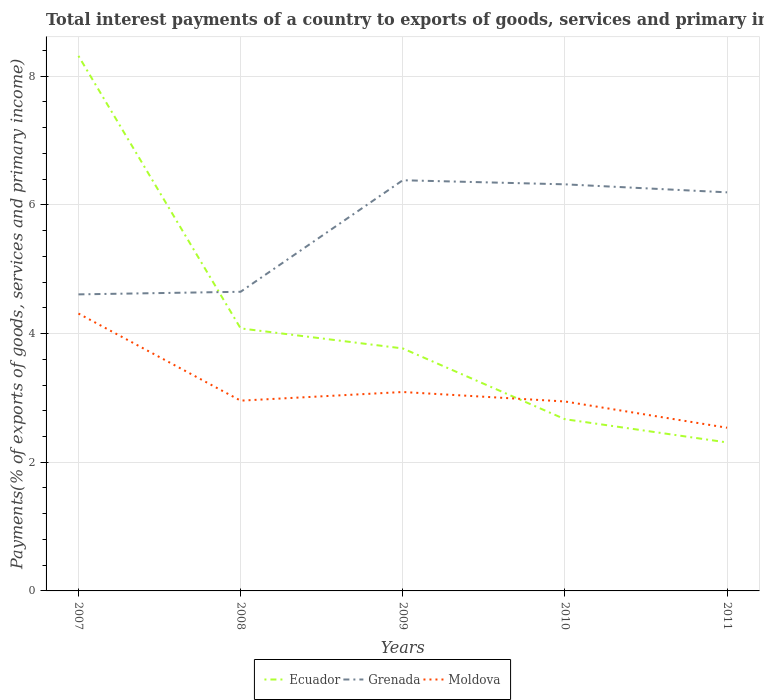How many different coloured lines are there?
Ensure brevity in your answer.  3. Across all years, what is the maximum total interest payments in Grenada?
Your answer should be compact. 4.61. In which year was the total interest payments in Moldova maximum?
Your answer should be compact. 2011. What is the total total interest payments in Ecuador in the graph?
Make the answer very short. 4.23. What is the difference between the highest and the second highest total interest payments in Moldova?
Ensure brevity in your answer.  1.77. What is the difference between the highest and the lowest total interest payments in Moldova?
Offer a terse response. 1. What is the difference between two consecutive major ticks on the Y-axis?
Your response must be concise. 2. Are the values on the major ticks of Y-axis written in scientific E-notation?
Offer a terse response. No. What is the title of the graph?
Ensure brevity in your answer.  Total interest payments of a country to exports of goods, services and primary income. What is the label or title of the X-axis?
Provide a succinct answer. Years. What is the label or title of the Y-axis?
Your answer should be very brief. Payments(% of exports of goods, services and primary income). What is the Payments(% of exports of goods, services and primary income) in Ecuador in 2007?
Make the answer very short. 8.32. What is the Payments(% of exports of goods, services and primary income) of Grenada in 2007?
Provide a succinct answer. 4.61. What is the Payments(% of exports of goods, services and primary income) in Moldova in 2007?
Make the answer very short. 4.31. What is the Payments(% of exports of goods, services and primary income) of Ecuador in 2008?
Offer a very short reply. 4.08. What is the Payments(% of exports of goods, services and primary income) of Grenada in 2008?
Your answer should be very brief. 4.65. What is the Payments(% of exports of goods, services and primary income) in Moldova in 2008?
Offer a very short reply. 2.96. What is the Payments(% of exports of goods, services and primary income) in Ecuador in 2009?
Your response must be concise. 3.77. What is the Payments(% of exports of goods, services and primary income) in Grenada in 2009?
Make the answer very short. 6.38. What is the Payments(% of exports of goods, services and primary income) in Moldova in 2009?
Ensure brevity in your answer.  3.09. What is the Payments(% of exports of goods, services and primary income) of Ecuador in 2010?
Provide a short and direct response. 2.67. What is the Payments(% of exports of goods, services and primary income) of Grenada in 2010?
Your response must be concise. 6.32. What is the Payments(% of exports of goods, services and primary income) of Moldova in 2010?
Provide a short and direct response. 2.94. What is the Payments(% of exports of goods, services and primary income) of Ecuador in 2011?
Provide a succinct answer. 2.31. What is the Payments(% of exports of goods, services and primary income) in Grenada in 2011?
Ensure brevity in your answer.  6.19. What is the Payments(% of exports of goods, services and primary income) of Moldova in 2011?
Offer a very short reply. 2.54. Across all years, what is the maximum Payments(% of exports of goods, services and primary income) in Ecuador?
Offer a terse response. 8.32. Across all years, what is the maximum Payments(% of exports of goods, services and primary income) in Grenada?
Ensure brevity in your answer.  6.38. Across all years, what is the maximum Payments(% of exports of goods, services and primary income) in Moldova?
Your response must be concise. 4.31. Across all years, what is the minimum Payments(% of exports of goods, services and primary income) in Ecuador?
Your answer should be compact. 2.31. Across all years, what is the minimum Payments(% of exports of goods, services and primary income) of Grenada?
Provide a succinct answer. 4.61. Across all years, what is the minimum Payments(% of exports of goods, services and primary income) of Moldova?
Ensure brevity in your answer.  2.54. What is the total Payments(% of exports of goods, services and primary income) in Ecuador in the graph?
Offer a terse response. 21.14. What is the total Payments(% of exports of goods, services and primary income) in Grenada in the graph?
Offer a terse response. 28.15. What is the total Payments(% of exports of goods, services and primary income) of Moldova in the graph?
Your answer should be compact. 15.84. What is the difference between the Payments(% of exports of goods, services and primary income) in Ecuador in 2007 and that in 2008?
Offer a terse response. 4.24. What is the difference between the Payments(% of exports of goods, services and primary income) of Grenada in 2007 and that in 2008?
Make the answer very short. -0.04. What is the difference between the Payments(% of exports of goods, services and primary income) in Moldova in 2007 and that in 2008?
Offer a very short reply. 1.35. What is the difference between the Payments(% of exports of goods, services and primary income) in Ecuador in 2007 and that in 2009?
Offer a terse response. 4.55. What is the difference between the Payments(% of exports of goods, services and primary income) of Grenada in 2007 and that in 2009?
Provide a succinct answer. -1.77. What is the difference between the Payments(% of exports of goods, services and primary income) of Moldova in 2007 and that in 2009?
Ensure brevity in your answer.  1.22. What is the difference between the Payments(% of exports of goods, services and primary income) of Ecuador in 2007 and that in 2010?
Provide a succinct answer. 5.65. What is the difference between the Payments(% of exports of goods, services and primary income) in Grenada in 2007 and that in 2010?
Ensure brevity in your answer.  -1.71. What is the difference between the Payments(% of exports of goods, services and primary income) in Moldova in 2007 and that in 2010?
Your answer should be very brief. 1.37. What is the difference between the Payments(% of exports of goods, services and primary income) of Ecuador in 2007 and that in 2011?
Your answer should be compact. 6.01. What is the difference between the Payments(% of exports of goods, services and primary income) in Grenada in 2007 and that in 2011?
Provide a short and direct response. -1.59. What is the difference between the Payments(% of exports of goods, services and primary income) in Moldova in 2007 and that in 2011?
Give a very brief answer. 1.77. What is the difference between the Payments(% of exports of goods, services and primary income) of Ecuador in 2008 and that in 2009?
Offer a very short reply. 0.31. What is the difference between the Payments(% of exports of goods, services and primary income) of Grenada in 2008 and that in 2009?
Your response must be concise. -1.73. What is the difference between the Payments(% of exports of goods, services and primary income) in Moldova in 2008 and that in 2009?
Offer a terse response. -0.13. What is the difference between the Payments(% of exports of goods, services and primary income) of Ecuador in 2008 and that in 2010?
Make the answer very short. 1.41. What is the difference between the Payments(% of exports of goods, services and primary income) in Grenada in 2008 and that in 2010?
Keep it short and to the point. -1.67. What is the difference between the Payments(% of exports of goods, services and primary income) of Moldova in 2008 and that in 2010?
Give a very brief answer. 0.01. What is the difference between the Payments(% of exports of goods, services and primary income) in Ecuador in 2008 and that in 2011?
Offer a very short reply. 1.77. What is the difference between the Payments(% of exports of goods, services and primary income) in Grenada in 2008 and that in 2011?
Your response must be concise. -1.55. What is the difference between the Payments(% of exports of goods, services and primary income) in Moldova in 2008 and that in 2011?
Your answer should be very brief. 0.42. What is the difference between the Payments(% of exports of goods, services and primary income) of Ecuador in 2009 and that in 2010?
Ensure brevity in your answer.  1.1. What is the difference between the Payments(% of exports of goods, services and primary income) in Grenada in 2009 and that in 2010?
Make the answer very short. 0.06. What is the difference between the Payments(% of exports of goods, services and primary income) in Moldova in 2009 and that in 2010?
Your answer should be very brief. 0.15. What is the difference between the Payments(% of exports of goods, services and primary income) in Ecuador in 2009 and that in 2011?
Provide a short and direct response. 1.46. What is the difference between the Payments(% of exports of goods, services and primary income) in Grenada in 2009 and that in 2011?
Your response must be concise. 0.19. What is the difference between the Payments(% of exports of goods, services and primary income) of Moldova in 2009 and that in 2011?
Your response must be concise. 0.56. What is the difference between the Payments(% of exports of goods, services and primary income) of Ecuador in 2010 and that in 2011?
Provide a succinct answer. 0.36. What is the difference between the Payments(% of exports of goods, services and primary income) of Grenada in 2010 and that in 2011?
Provide a short and direct response. 0.12. What is the difference between the Payments(% of exports of goods, services and primary income) in Moldova in 2010 and that in 2011?
Your answer should be very brief. 0.41. What is the difference between the Payments(% of exports of goods, services and primary income) of Ecuador in 2007 and the Payments(% of exports of goods, services and primary income) of Grenada in 2008?
Your answer should be very brief. 3.67. What is the difference between the Payments(% of exports of goods, services and primary income) of Ecuador in 2007 and the Payments(% of exports of goods, services and primary income) of Moldova in 2008?
Provide a succinct answer. 5.36. What is the difference between the Payments(% of exports of goods, services and primary income) of Grenada in 2007 and the Payments(% of exports of goods, services and primary income) of Moldova in 2008?
Offer a very short reply. 1.65. What is the difference between the Payments(% of exports of goods, services and primary income) in Ecuador in 2007 and the Payments(% of exports of goods, services and primary income) in Grenada in 2009?
Your answer should be compact. 1.93. What is the difference between the Payments(% of exports of goods, services and primary income) in Ecuador in 2007 and the Payments(% of exports of goods, services and primary income) in Moldova in 2009?
Offer a terse response. 5.22. What is the difference between the Payments(% of exports of goods, services and primary income) in Grenada in 2007 and the Payments(% of exports of goods, services and primary income) in Moldova in 2009?
Provide a succinct answer. 1.52. What is the difference between the Payments(% of exports of goods, services and primary income) in Ecuador in 2007 and the Payments(% of exports of goods, services and primary income) in Grenada in 2010?
Keep it short and to the point. 2. What is the difference between the Payments(% of exports of goods, services and primary income) of Ecuador in 2007 and the Payments(% of exports of goods, services and primary income) of Moldova in 2010?
Your answer should be compact. 5.37. What is the difference between the Payments(% of exports of goods, services and primary income) in Grenada in 2007 and the Payments(% of exports of goods, services and primary income) in Moldova in 2010?
Ensure brevity in your answer.  1.66. What is the difference between the Payments(% of exports of goods, services and primary income) in Ecuador in 2007 and the Payments(% of exports of goods, services and primary income) in Grenada in 2011?
Provide a short and direct response. 2.12. What is the difference between the Payments(% of exports of goods, services and primary income) of Ecuador in 2007 and the Payments(% of exports of goods, services and primary income) of Moldova in 2011?
Your answer should be very brief. 5.78. What is the difference between the Payments(% of exports of goods, services and primary income) of Grenada in 2007 and the Payments(% of exports of goods, services and primary income) of Moldova in 2011?
Offer a terse response. 2.07. What is the difference between the Payments(% of exports of goods, services and primary income) in Ecuador in 2008 and the Payments(% of exports of goods, services and primary income) in Grenada in 2009?
Ensure brevity in your answer.  -2.3. What is the difference between the Payments(% of exports of goods, services and primary income) of Ecuador in 2008 and the Payments(% of exports of goods, services and primary income) of Moldova in 2009?
Ensure brevity in your answer.  0.99. What is the difference between the Payments(% of exports of goods, services and primary income) of Grenada in 2008 and the Payments(% of exports of goods, services and primary income) of Moldova in 2009?
Offer a very short reply. 1.56. What is the difference between the Payments(% of exports of goods, services and primary income) of Ecuador in 2008 and the Payments(% of exports of goods, services and primary income) of Grenada in 2010?
Give a very brief answer. -2.24. What is the difference between the Payments(% of exports of goods, services and primary income) of Ecuador in 2008 and the Payments(% of exports of goods, services and primary income) of Moldova in 2010?
Ensure brevity in your answer.  1.14. What is the difference between the Payments(% of exports of goods, services and primary income) of Grenada in 2008 and the Payments(% of exports of goods, services and primary income) of Moldova in 2010?
Your answer should be very brief. 1.71. What is the difference between the Payments(% of exports of goods, services and primary income) in Ecuador in 2008 and the Payments(% of exports of goods, services and primary income) in Grenada in 2011?
Make the answer very short. -2.11. What is the difference between the Payments(% of exports of goods, services and primary income) in Ecuador in 2008 and the Payments(% of exports of goods, services and primary income) in Moldova in 2011?
Give a very brief answer. 1.54. What is the difference between the Payments(% of exports of goods, services and primary income) of Grenada in 2008 and the Payments(% of exports of goods, services and primary income) of Moldova in 2011?
Offer a terse response. 2.11. What is the difference between the Payments(% of exports of goods, services and primary income) of Ecuador in 2009 and the Payments(% of exports of goods, services and primary income) of Grenada in 2010?
Provide a short and direct response. -2.55. What is the difference between the Payments(% of exports of goods, services and primary income) of Ecuador in 2009 and the Payments(% of exports of goods, services and primary income) of Moldova in 2010?
Keep it short and to the point. 0.82. What is the difference between the Payments(% of exports of goods, services and primary income) of Grenada in 2009 and the Payments(% of exports of goods, services and primary income) of Moldova in 2010?
Your response must be concise. 3.44. What is the difference between the Payments(% of exports of goods, services and primary income) of Ecuador in 2009 and the Payments(% of exports of goods, services and primary income) of Grenada in 2011?
Give a very brief answer. -2.43. What is the difference between the Payments(% of exports of goods, services and primary income) in Ecuador in 2009 and the Payments(% of exports of goods, services and primary income) in Moldova in 2011?
Provide a short and direct response. 1.23. What is the difference between the Payments(% of exports of goods, services and primary income) in Grenada in 2009 and the Payments(% of exports of goods, services and primary income) in Moldova in 2011?
Ensure brevity in your answer.  3.85. What is the difference between the Payments(% of exports of goods, services and primary income) in Ecuador in 2010 and the Payments(% of exports of goods, services and primary income) in Grenada in 2011?
Make the answer very short. -3.53. What is the difference between the Payments(% of exports of goods, services and primary income) in Ecuador in 2010 and the Payments(% of exports of goods, services and primary income) in Moldova in 2011?
Ensure brevity in your answer.  0.13. What is the difference between the Payments(% of exports of goods, services and primary income) of Grenada in 2010 and the Payments(% of exports of goods, services and primary income) of Moldova in 2011?
Offer a terse response. 3.78. What is the average Payments(% of exports of goods, services and primary income) of Ecuador per year?
Make the answer very short. 4.23. What is the average Payments(% of exports of goods, services and primary income) of Grenada per year?
Make the answer very short. 5.63. What is the average Payments(% of exports of goods, services and primary income) of Moldova per year?
Offer a very short reply. 3.17. In the year 2007, what is the difference between the Payments(% of exports of goods, services and primary income) in Ecuador and Payments(% of exports of goods, services and primary income) in Grenada?
Provide a short and direct response. 3.71. In the year 2007, what is the difference between the Payments(% of exports of goods, services and primary income) of Ecuador and Payments(% of exports of goods, services and primary income) of Moldova?
Offer a very short reply. 4. In the year 2007, what is the difference between the Payments(% of exports of goods, services and primary income) in Grenada and Payments(% of exports of goods, services and primary income) in Moldova?
Offer a very short reply. 0.3. In the year 2008, what is the difference between the Payments(% of exports of goods, services and primary income) of Ecuador and Payments(% of exports of goods, services and primary income) of Grenada?
Provide a succinct answer. -0.57. In the year 2008, what is the difference between the Payments(% of exports of goods, services and primary income) of Ecuador and Payments(% of exports of goods, services and primary income) of Moldova?
Ensure brevity in your answer.  1.12. In the year 2008, what is the difference between the Payments(% of exports of goods, services and primary income) of Grenada and Payments(% of exports of goods, services and primary income) of Moldova?
Your answer should be very brief. 1.69. In the year 2009, what is the difference between the Payments(% of exports of goods, services and primary income) of Ecuador and Payments(% of exports of goods, services and primary income) of Grenada?
Make the answer very short. -2.61. In the year 2009, what is the difference between the Payments(% of exports of goods, services and primary income) of Ecuador and Payments(% of exports of goods, services and primary income) of Moldova?
Make the answer very short. 0.68. In the year 2009, what is the difference between the Payments(% of exports of goods, services and primary income) in Grenada and Payments(% of exports of goods, services and primary income) in Moldova?
Ensure brevity in your answer.  3.29. In the year 2010, what is the difference between the Payments(% of exports of goods, services and primary income) of Ecuador and Payments(% of exports of goods, services and primary income) of Grenada?
Provide a succinct answer. -3.65. In the year 2010, what is the difference between the Payments(% of exports of goods, services and primary income) of Ecuador and Payments(% of exports of goods, services and primary income) of Moldova?
Ensure brevity in your answer.  -0.28. In the year 2010, what is the difference between the Payments(% of exports of goods, services and primary income) in Grenada and Payments(% of exports of goods, services and primary income) in Moldova?
Offer a terse response. 3.37. In the year 2011, what is the difference between the Payments(% of exports of goods, services and primary income) of Ecuador and Payments(% of exports of goods, services and primary income) of Grenada?
Provide a succinct answer. -3.89. In the year 2011, what is the difference between the Payments(% of exports of goods, services and primary income) in Ecuador and Payments(% of exports of goods, services and primary income) in Moldova?
Make the answer very short. -0.23. In the year 2011, what is the difference between the Payments(% of exports of goods, services and primary income) of Grenada and Payments(% of exports of goods, services and primary income) of Moldova?
Your response must be concise. 3.66. What is the ratio of the Payments(% of exports of goods, services and primary income) in Ecuador in 2007 to that in 2008?
Make the answer very short. 2.04. What is the ratio of the Payments(% of exports of goods, services and primary income) in Grenada in 2007 to that in 2008?
Your answer should be very brief. 0.99. What is the ratio of the Payments(% of exports of goods, services and primary income) in Moldova in 2007 to that in 2008?
Give a very brief answer. 1.46. What is the ratio of the Payments(% of exports of goods, services and primary income) of Ecuador in 2007 to that in 2009?
Make the answer very short. 2.21. What is the ratio of the Payments(% of exports of goods, services and primary income) in Grenada in 2007 to that in 2009?
Ensure brevity in your answer.  0.72. What is the ratio of the Payments(% of exports of goods, services and primary income) in Moldova in 2007 to that in 2009?
Offer a terse response. 1.39. What is the ratio of the Payments(% of exports of goods, services and primary income) in Ecuador in 2007 to that in 2010?
Offer a terse response. 3.12. What is the ratio of the Payments(% of exports of goods, services and primary income) in Grenada in 2007 to that in 2010?
Your response must be concise. 0.73. What is the ratio of the Payments(% of exports of goods, services and primary income) in Moldova in 2007 to that in 2010?
Your answer should be very brief. 1.46. What is the ratio of the Payments(% of exports of goods, services and primary income) in Ecuador in 2007 to that in 2011?
Your answer should be compact. 3.6. What is the ratio of the Payments(% of exports of goods, services and primary income) in Grenada in 2007 to that in 2011?
Make the answer very short. 0.74. What is the ratio of the Payments(% of exports of goods, services and primary income) in Moldova in 2007 to that in 2011?
Make the answer very short. 1.7. What is the ratio of the Payments(% of exports of goods, services and primary income) of Ecuador in 2008 to that in 2009?
Provide a short and direct response. 1.08. What is the ratio of the Payments(% of exports of goods, services and primary income) in Grenada in 2008 to that in 2009?
Ensure brevity in your answer.  0.73. What is the ratio of the Payments(% of exports of goods, services and primary income) of Moldova in 2008 to that in 2009?
Make the answer very short. 0.96. What is the ratio of the Payments(% of exports of goods, services and primary income) in Ecuador in 2008 to that in 2010?
Ensure brevity in your answer.  1.53. What is the ratio of the Payments(% of exports of goods, services and primary income) in Grenada in 2008 to that in 2010?
Make the answer very short. 0.74. What is the ratio of the Payments(% of exports of goods, services and primary income) of Ecuador in 2008 to that in 2011?
Provide a succinct answer. 1.77. What is the ratio of the Payments(% of exports of goods, services and primary income) of Grenada in 2008 to that in 2011?
Provide a short and direct response. 0.75. What is the ratio of the Payments(% of exports of goods, services and primary income) of Moldova in 2008 to that in 2011?
Make the answer very short. 1.17. What is the ratio of the Payments(% of exports of goods, services and primary income) in Ecuador in 2009 to that in 2010?
Your response must be concise. 1.41. What is the ratio of the Payments(% of exports of goods, services and primary income) of Grenada in 2009 to that in 2010?
Your answer should be very brief. 1.01. What is the ratio of the Payments(% of exports of goods, services and primary income) of Moldova in 2009 to that in 2010?
Offer a very short reply. 1.05. What is the ratio of the Payments(% of exports of goods, services and primary income) in Ecuador in 2009 to that in 2011?
Offer a very short reply. 1.63. What is the ratio of the Payments(% of exports of goods, services and primary income) of Grenada in 2009 to that in 2011?
Provide a short and direct response. 1.03. What is the ratio of the Payments(% of exports of goods, services and primary income) of Moldova in 2009 to that in 2011?
Your answer should be very brief. 1.22. What is the ratio of the Payments(% of exports of goods, services and primary income) in Ecuador in 2010 to that in 2011?
Provide a short and direct response. 1.16. What is the ratio of the Payments(% of exports of goods, services and primary income) of Grenada in 2010 to that in 2011?
Your response must be concise. 1.02. What is the ratio of the Payments(% of exports of goods, services and primary income) in Moldova in 2010 to that in 2011?
Make the answer very short. 1.16. What is the difference between the highest and the second highest Payments(% of exports of goods, services and primary income) in Ecuador?
Offer a very short reply. 4.24. What is the difference between the highest and the second highest Payments(% of exports of goods, services and primary income) in Grenada?
Offer a very short reply. 0.06. What is the difference between the highest and the second highest Payments(% of exports of goods, services and primary income) in Moldova?
Provide a short and direct response. 1.22. What is the difference between the highest and the lowest Payments(% of exports of goods, services and primary income) of Ecuador?
Your response must be concise. 6.01. What is the difference between the highest and the lowest Payments(% of exports of goods, services and primary income) of Grenada?
Offer a very short reply. 1.77. What is the difference between the highest and the lowest Payments(% of exports of goods, services and primary income) in Moldova?
Your answer should be compact. 1.77. 